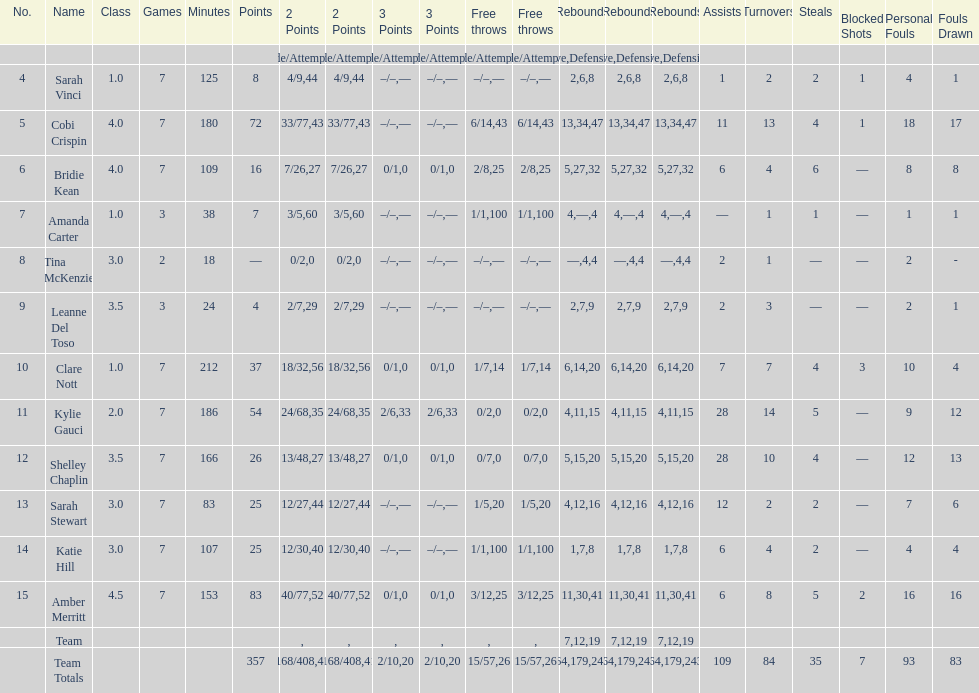Who had more steals than any other player? Bridie Kean. 